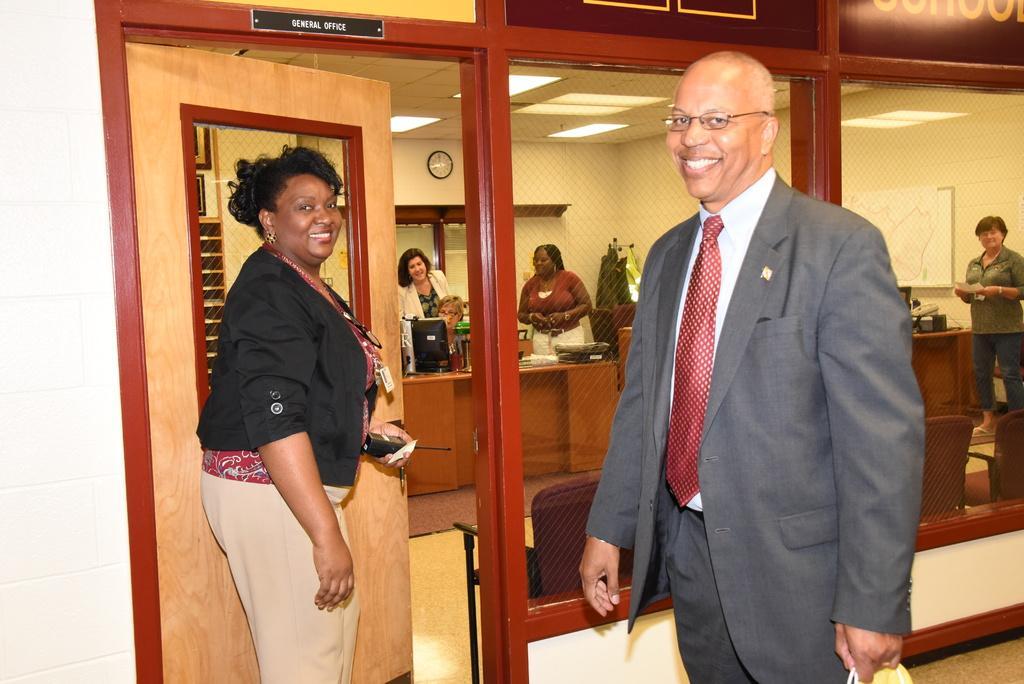Please provide a concise description of this image. In the background we can see a clock on the wall. In this picture we can see lights, objects, ceiling, boards, tables, chairs, door, floor and people. We can see a person is sitting and other people are standing. On the right side of the picture we can see a man wearing a blazer, spectacles and he is holding an object. He is smiling. We can see a woman standing, holding walkie talkie and smiling. 